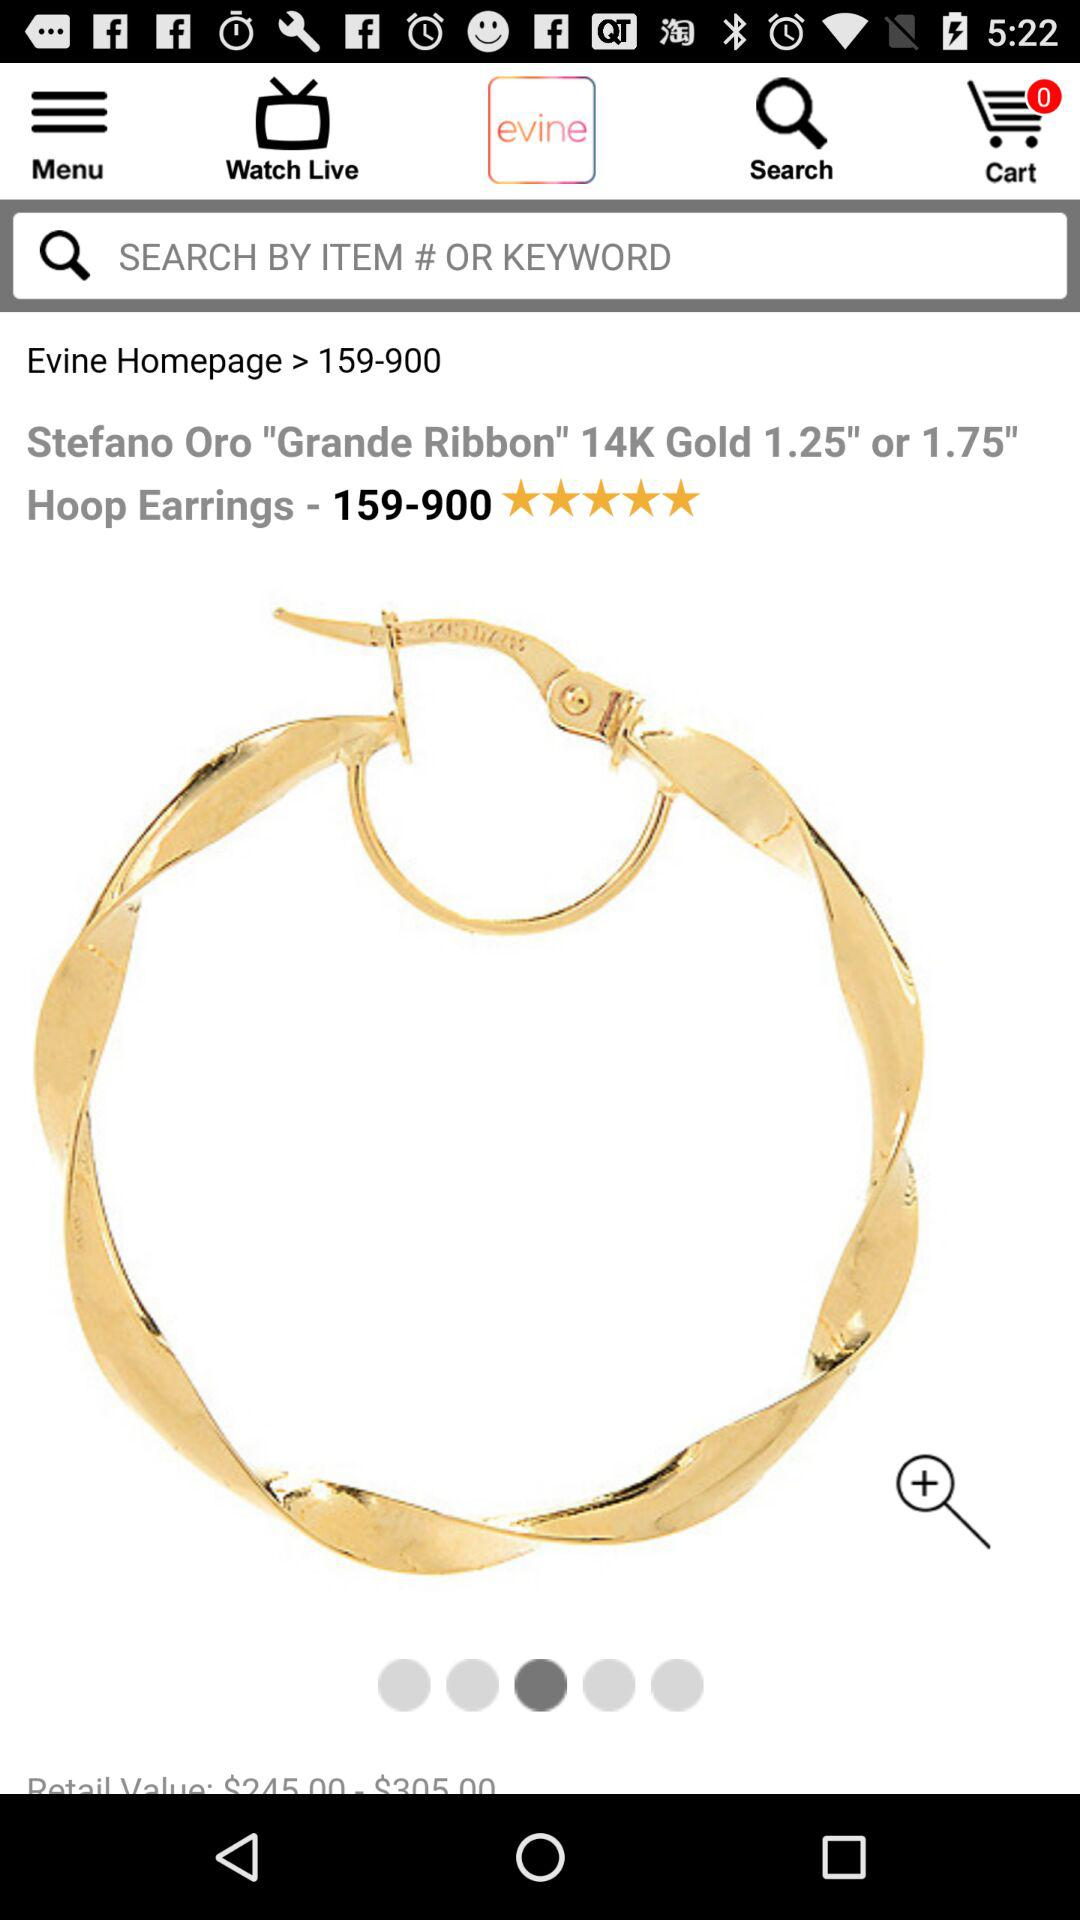How many items are shown in the cart? There are 0 items in the cart. 